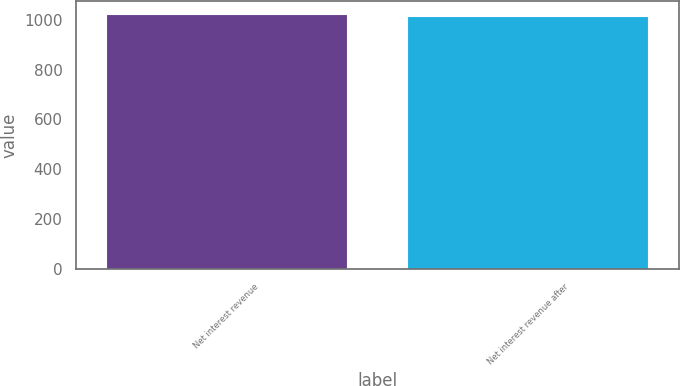<chart> <loc_0><loc_0><loc_500><loc_500><bar_chart><fcel>Net interest revenue<fcel>Net interest revenue after<nl><fcel>1025<fcel>1015<nl></chart> 